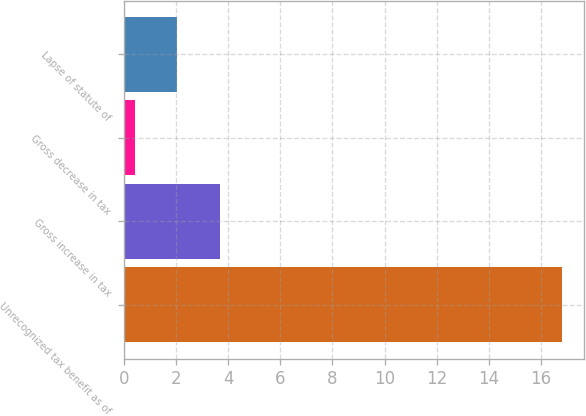Convert chart. <chart><loc_0><loc_0><loc_500><loc_500><bar_chart><fcel>Unrecognized tax benefit as of<fcel>Gross increase in tax<fcel>Gross decrease in tax<fcel>Lapse of statute of<nl><fcel>16.8<fcel>3.68<fcel>0.4<fcel>2.04<nl></chart> 